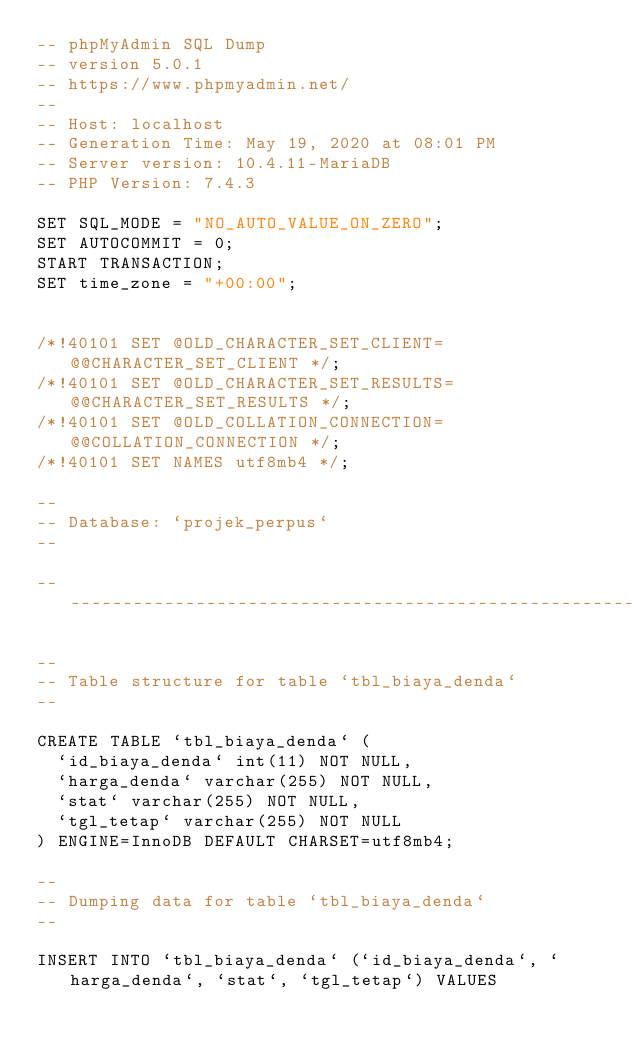Convert code to text. <code><loc_0><loc_0><loc_500><loc_500><_SQL_>-- phpMyAdmin SQL Dump
-- version 5.0.1
-- https://www.phpmyadmin.net/
--
-- Host: localhost
-- Generation Time: May 19, 2020 at 08:01 PM
-- Server version: 10.4.11-MariaDB
-- PHP Version: 7.4.3

SET SQL_MODE = "NO_AUTO_VALUE_ON_ZERO";
SET AUTOCOMMIT = 0;
START TRANSACTION;
SET time_zone = "+00:00";


/*!40101 SET @OLD_CHARACTER_SET_CLIENT=@@CHARACTER_SET_CLIENT */;
/*!40101 SET @OLD_CHARACTER_SET_RESULTS=@@CHARACTER_SET_RESULTS */;
/*!40101 SET @OLD_COLLATION_CONNECTION=@@COLLATION_CONNECTION */;
/*!40101 SET NAMES utf8mb4 */;

--
-- Database: `projek_perpus`
--

-- --------------------------------------------------------

--
-- Table structure for table `tbl_biaya_denda`
--

CREATE TABLE `tbl_biaya_denda` (
  `id_biaya_denda` int(11) NOT NULL,
  `harga_denda` varchar(255) NOT NULL,
  `stat` varchar(255) NOT NULL,
  `tgl_tetap` varchar(255) NOT NULL
) ENGINE=InnoDB DEFAULT CHARSET=utf8mb4;

--
-- Dumping data for table `tbl_biaya_denda`
--

INSERT INTO `tbl_biaya_denda` (`id_biaya_denda`, `harga_denda`, `stat`, `tgl_tetap`) VALUES</code> 